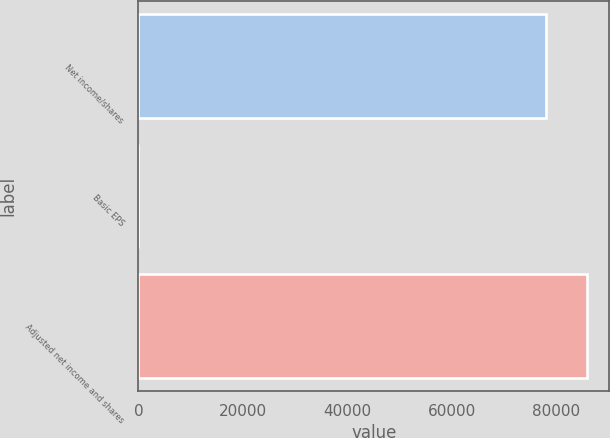Convert chart to OTSL. <chart><loc_0><loc_0><loc_500><loc_500><bar_chart><fcel>Net income/shares<fcel>Basic EPS<fcel>Adjusted net income and shares<nl><fcel>77992<fcel>1.37<fcel>85791.1<nl></chart> 